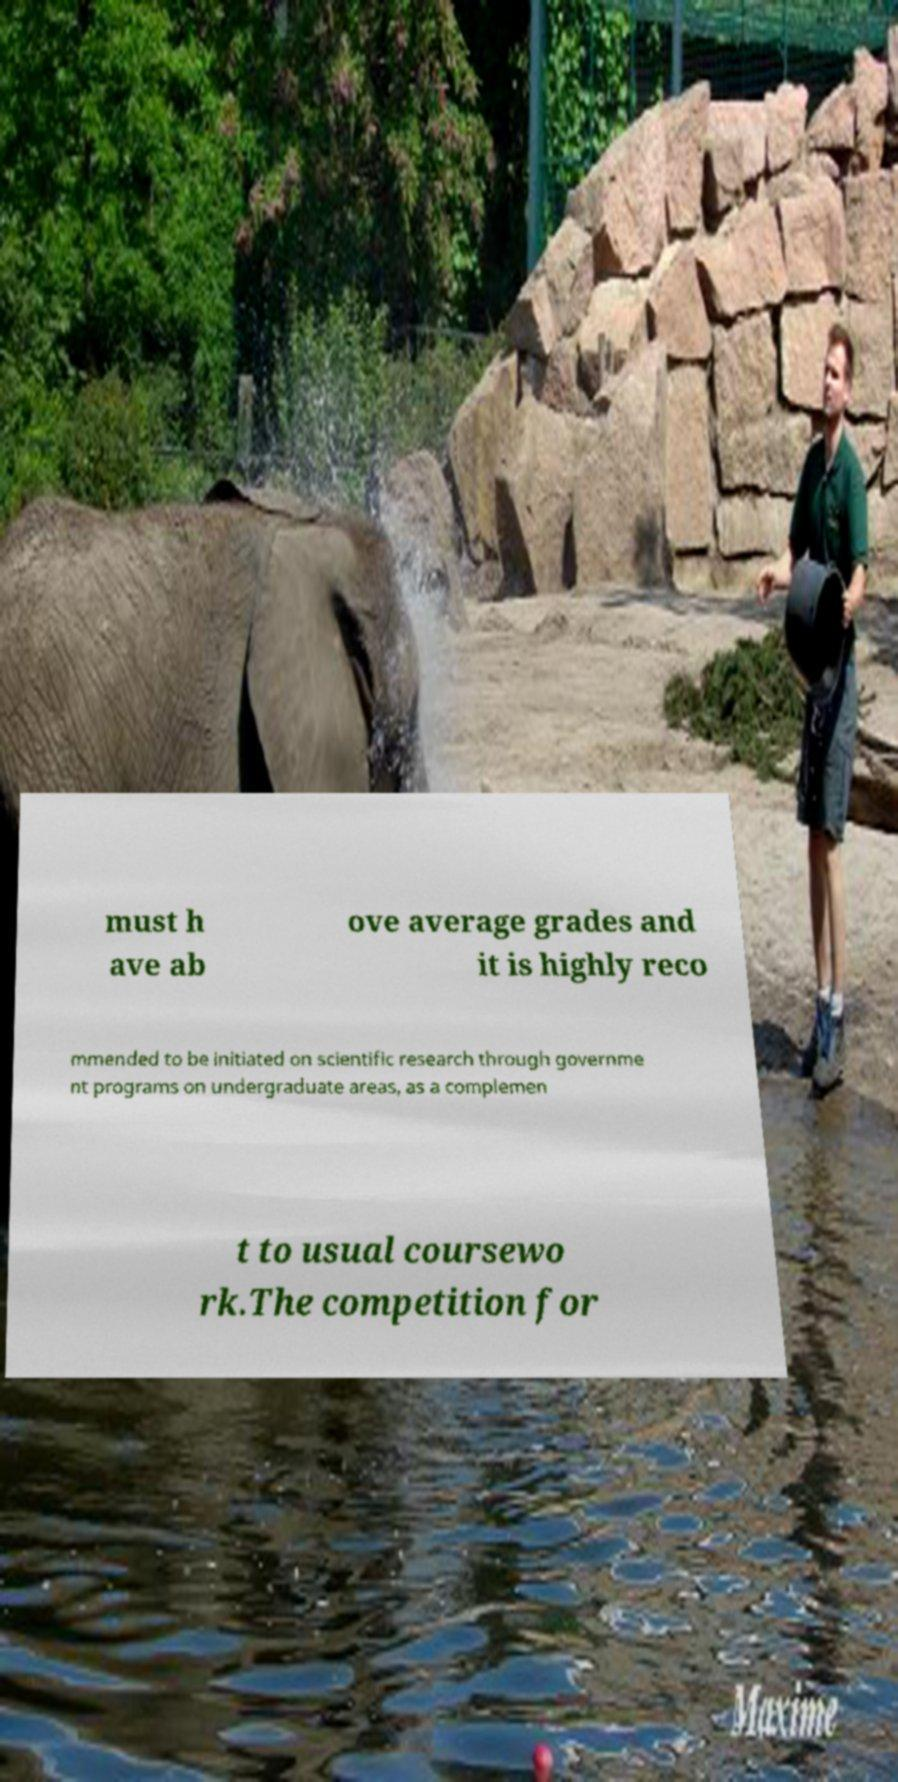Could you assist in decoding the text presented in this image and type it out clearly? must h ave ab ove average grades and it is highly reco mmended to be initiated on scientific research through governme nt programs on undergraduate areas, as a complemen t to usual coursewo rk.The competition for 